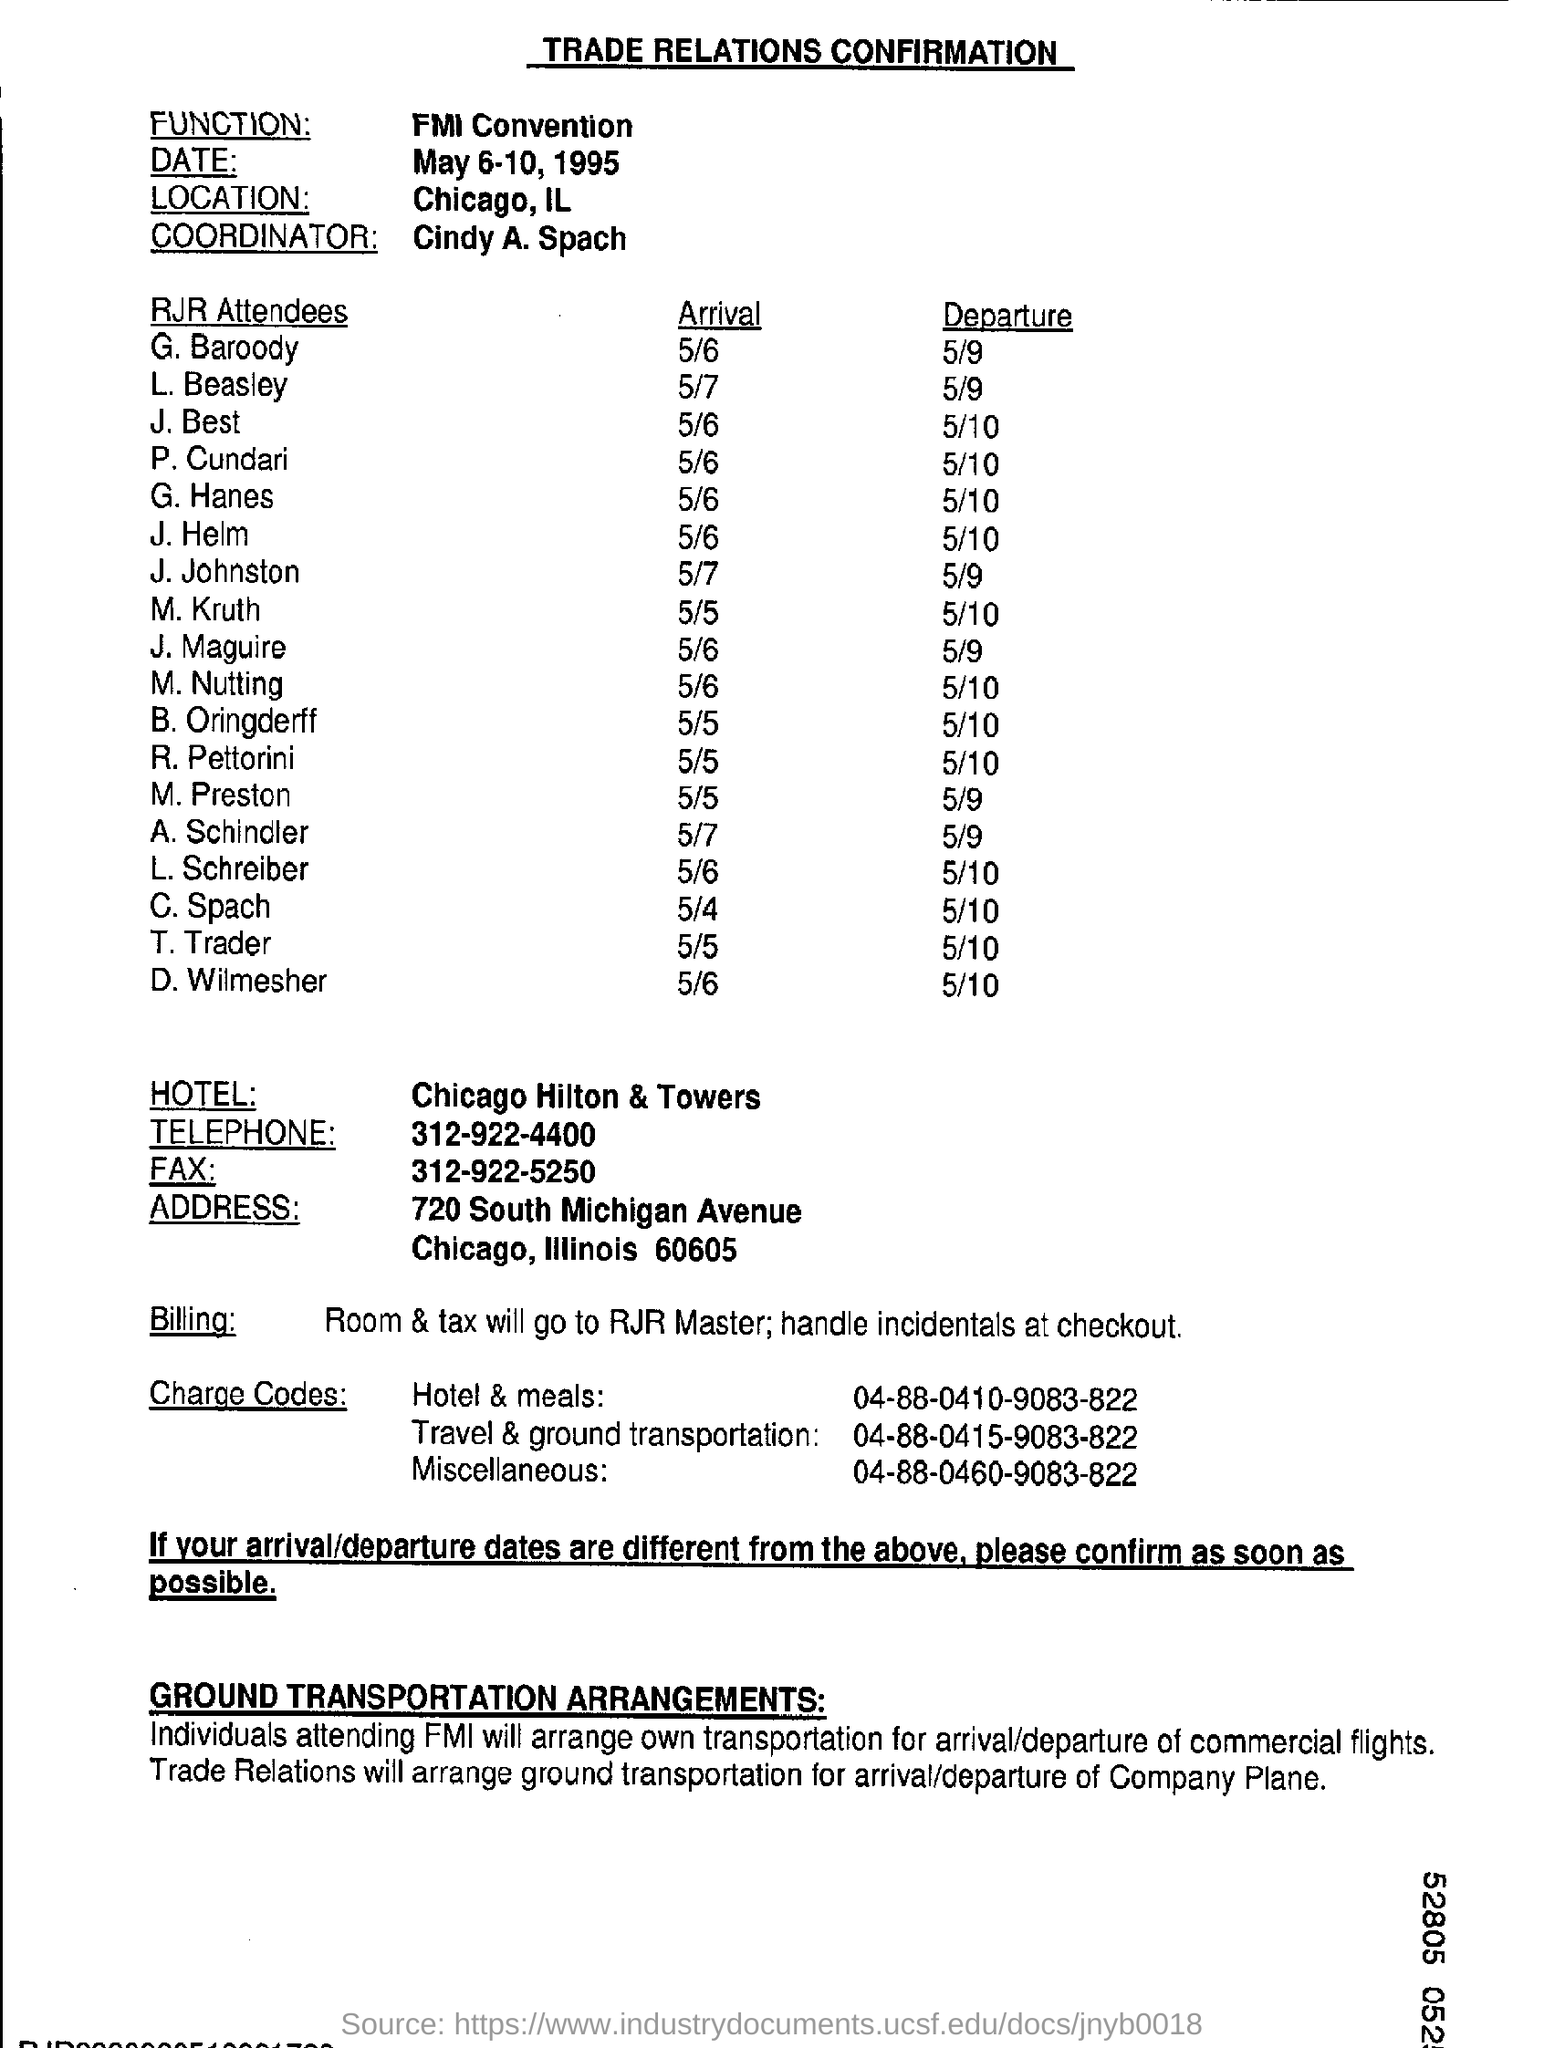Indicate a few pertinent items in this graphic. The name of the hotel is the Chicago Hilton & Towers. The charge code for hotel and meals is 04-88-0410-9083-822. The arrival date of T. Trader is May 5th. Cindy A. Spach is the coordinator. 